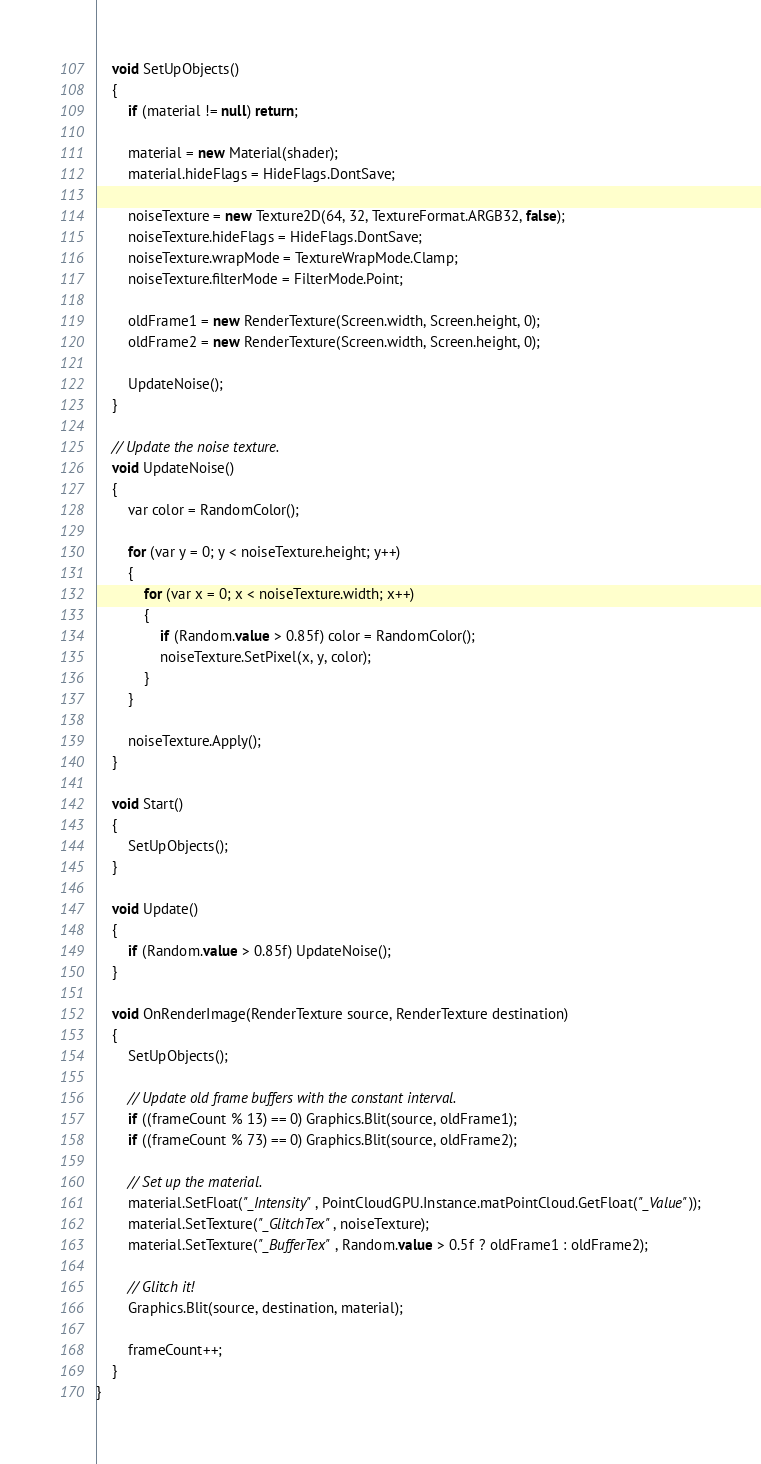<code> <loc_0><loc_0><loc_500><loc_500><_C#_>    void SetUpObjects()
    {
        if (material != null) return;

        material = new Material(shader);
        material.hideFlags = HideFlags.DontSave;

        noiseTexture = new Texture2D(64, 32, TextureFormat.ARGB32, false);
        noiseTexture.hideFlags = HideFlags.DontSave;
        noiseTexture.wrapMode = TextureWrapMode.Clamp;
        noiseTexture.filterMode = FilterMode.Point;

        oldFrame1 = new RenderTexture(Screen.width, Screen.height, 0);
        oldFrame2 = new RenderTexture(Screen.width, Screen.height, 0);

        UpdateNoise();
    }

    // Update the noise texture.
    void UpdateNoise()
    {
        var color = RandomColor();

        for (var y = 0; y < noiseTexture.height; y++)
        {
            for (var x = 0; x < noiseTexture.width; x++)
            {
                if (Random.value > 0.85f) color = RandomColor();
                noiseTexture.SetPixel(x, y, color);
            }
        }

        noiseTexture.Apply();
    }

    void Start()
    {
        SetUpObjects();
    }

    void Update()
    {
        if (Random.value > 0.85f) UpdateNoise();
    }

    void OnRenderImage(RenderTexture source, RenderTexture destination)
    {
        SetUpObjects();

        // Update old frame buffers with the constant interval.
        if ((frameCount % 13) == 0) Graphics.Blit(source, oldFrame1);
        if ((frameCount % 73) == 0) Graphics.Blit(source, oldFrame2);

        // Set up the material.
        material.SetFloat("_Intensity", PointCloudGPU.Instance.matPointCloud.GetFloat("_Value"));
        material.SetTexture("_GlitchTex", noiseTexture);
        material.SetTexture("_BufferTex", Random.value > 0.5f ? oldFrame1 : oldFrame2);

        // Glitch it!
        Graphics.Blit(source, destination, material);

        frameCount++;
    }
}
</code> 